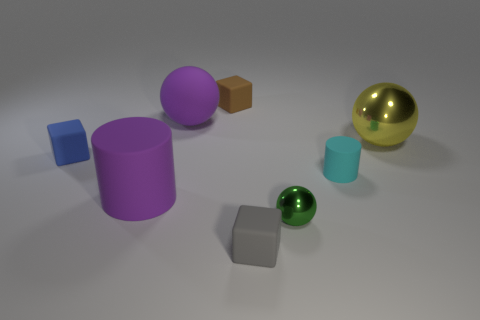Which objects in this image look like they have metallic surfaces? The objects with metallic surfaces are the large spheres. One is gold and positioned on the right side of the image, and the other is green with a smaller size, located slightly to its left and closer to the center. Are there any patterns or themes that these objects could represent? These objects could be interpreted in several ways. The arrangement and variety of shapes and colors might represent diversity and coexistence. Alternatively, the neatly spaced and non-overlapping positioning of the objects could symbolize order and balance. 